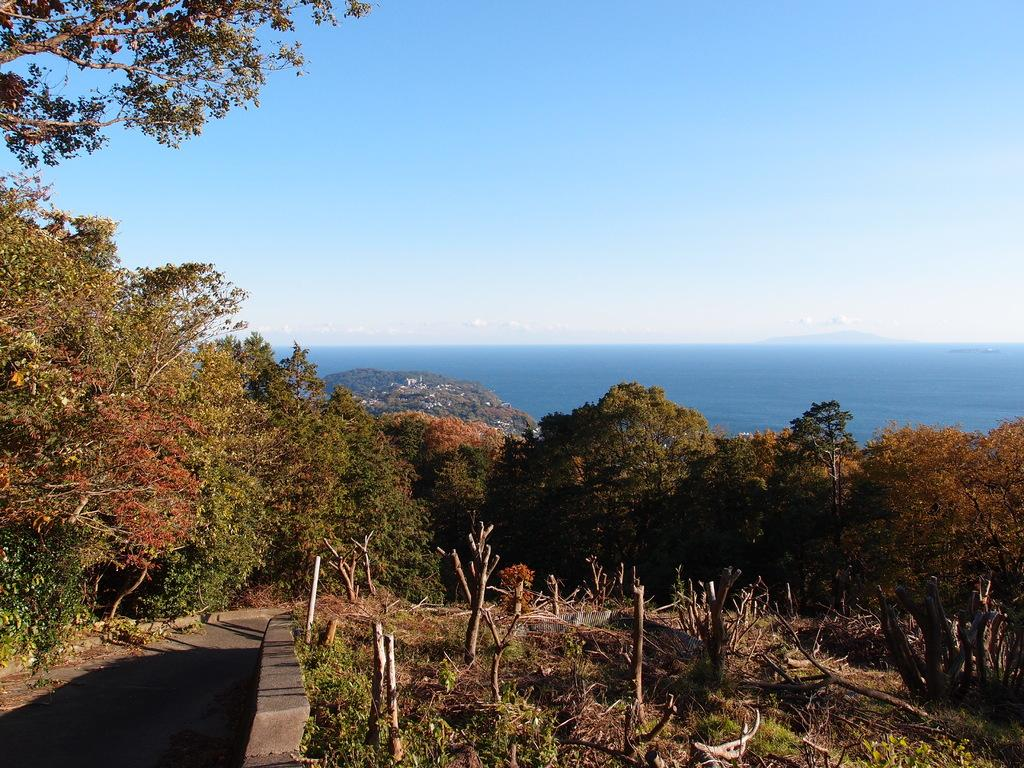What type of natural elements can be seen in the image? There are trees and water visible in the image. What man-made structure is present in the image? There is a road in the image. What is visible in the background of the image? The sky is visible in the image, and clouds are present in the sky. What type of hat is the tree wearing in the image? There are no hats present in the image, as trees do not wear hats. Is there a band performing in the image? There is no band or performance depicted in the image. 